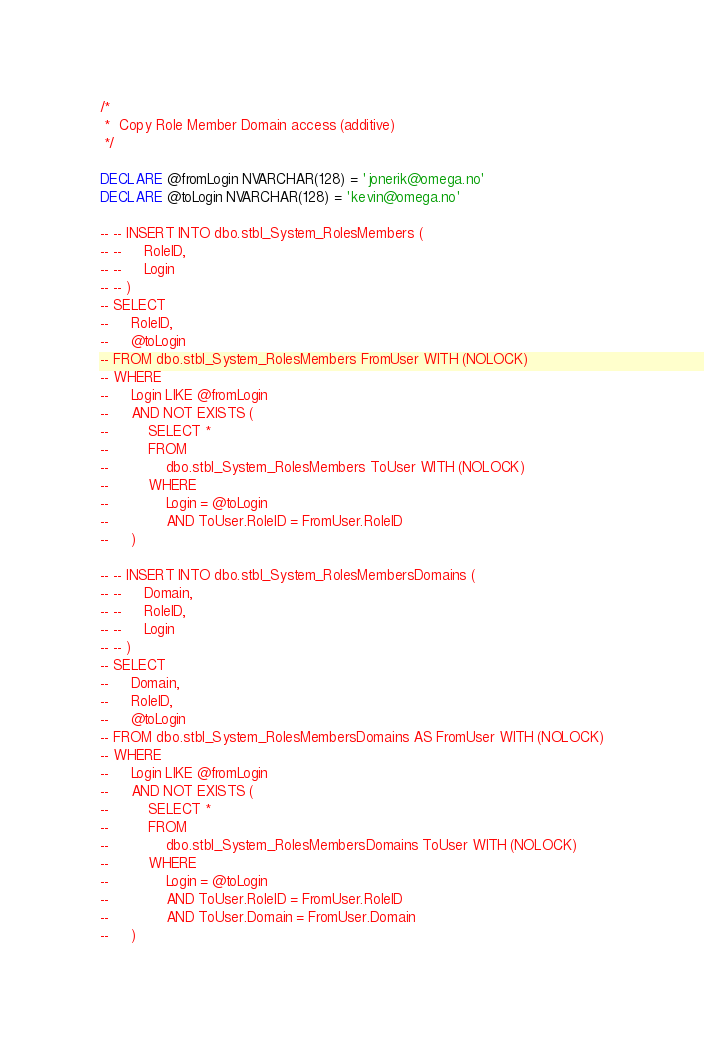<code> <loc_0><loc_0><loc_500><loc_500><_SQL_>
/*
 *  Copy Role Member Domain access (additive)
 */

DECLARE @fromLogin NVARCHAR(128) = 'jonerik@omega.no'
DECLARE @toLogin NVARCHAR(128) = 'kevin@omega.no'

-- -- INSERT INTO dbo.stbl_System_RolesMembers (
-- --     RoleID,
-- --     Login
-- -- )
-- SELECT
--     RoleID,
--     @toLogin
-- FROM dbo.stbl_System_RolesMembers FromUser WITH (NOLOCK)
-- WHERE
--     Login LIKE @fromLogin
--     AND NOT EXISTS (
--         SELECT *
--         FROM
--             dbo.stbl_System_RolesMembers ToUser WITH (NOLOCK)
--         WHERE
--             Login = @toLogin
--             AND ToUser.RoleID = FromUser.RoleID
--     )

-- -- INSERT INTO dbo.stbl_System_RolesMembersDomains (
-- --     Domain,
-- --     RoleID,
-- --     Login
-- -- )
-- SELECT
--     Domain,
--     RoleID,
--     @toLogin
-- FROM dbo.stbl_System_RolesMembersDomains AS FromUser WITH (NOLOCK)
-- WHERE
--     Login LIKE @fromLogin
--     AND NOT EXISTS (
--         SELECT *
--         FROM
--             dbo.stbl_System_RolesMembersDomains ToUser WITH (NOLOCK)
--         WHERE
--             Login = @toLogin
--             AND ToUser.RoleID = FromUser.RoleID
--             AND ToUser.Domain = FromUser.Domain
--     )
</code> 